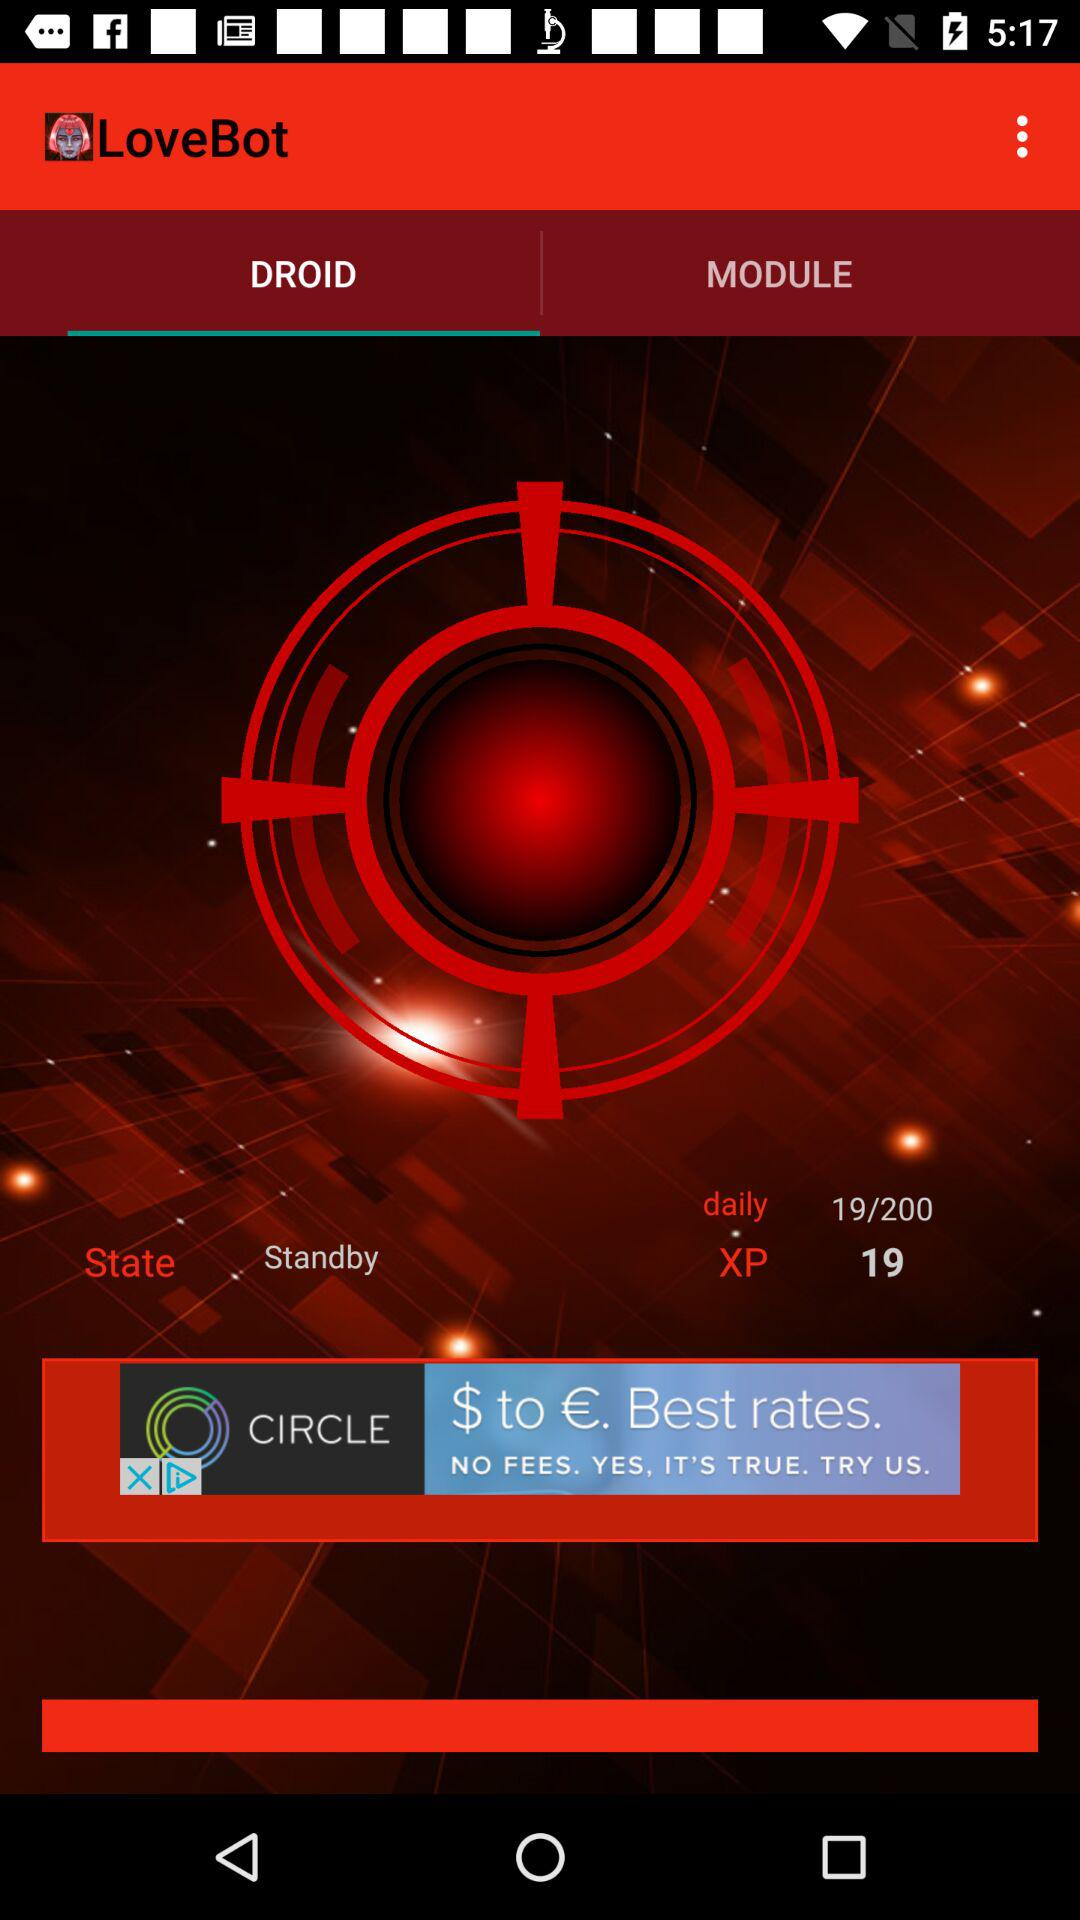What is the application name? The application name is "LoveBot". 